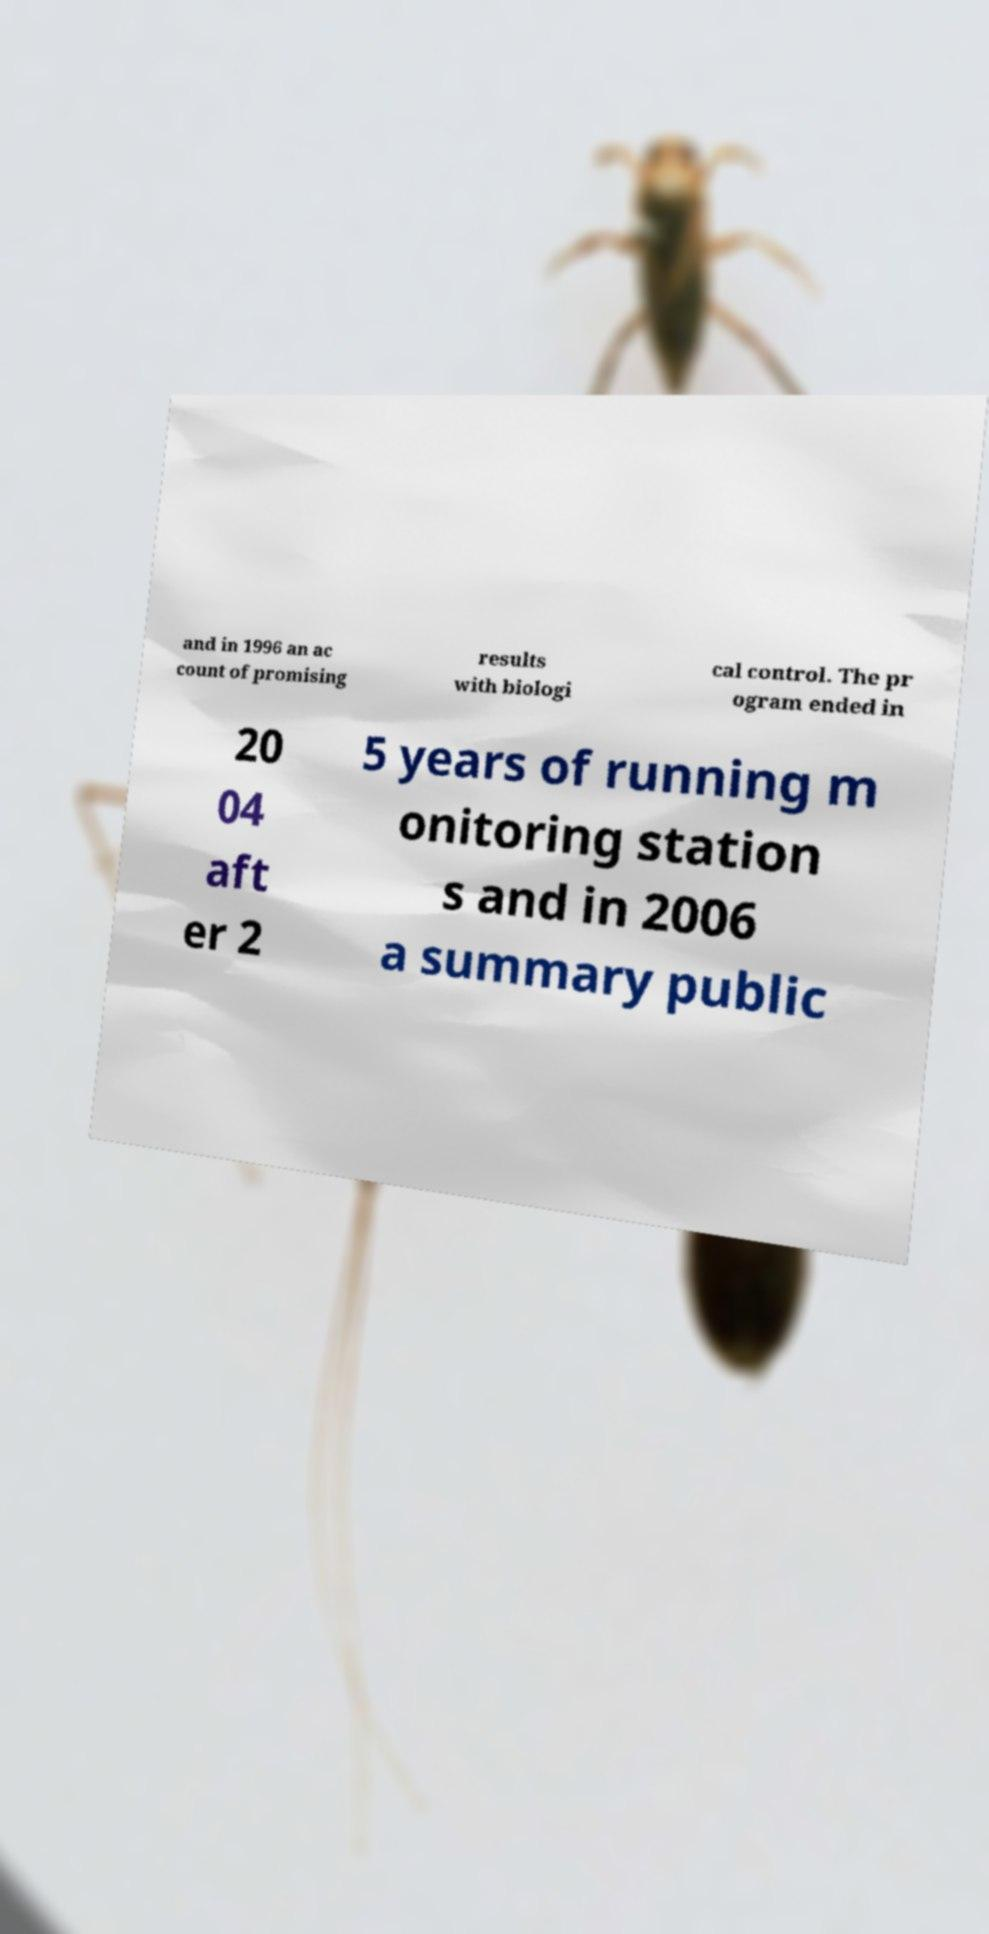Could you assist in decoding the text presented in this image and type it out clearly? and in 1996 an ac count of promising results with biologi cal control. The pr ogram ended in 20 04 aft er 2 5 years of running m onitoring station s and in 2006 a summary public 